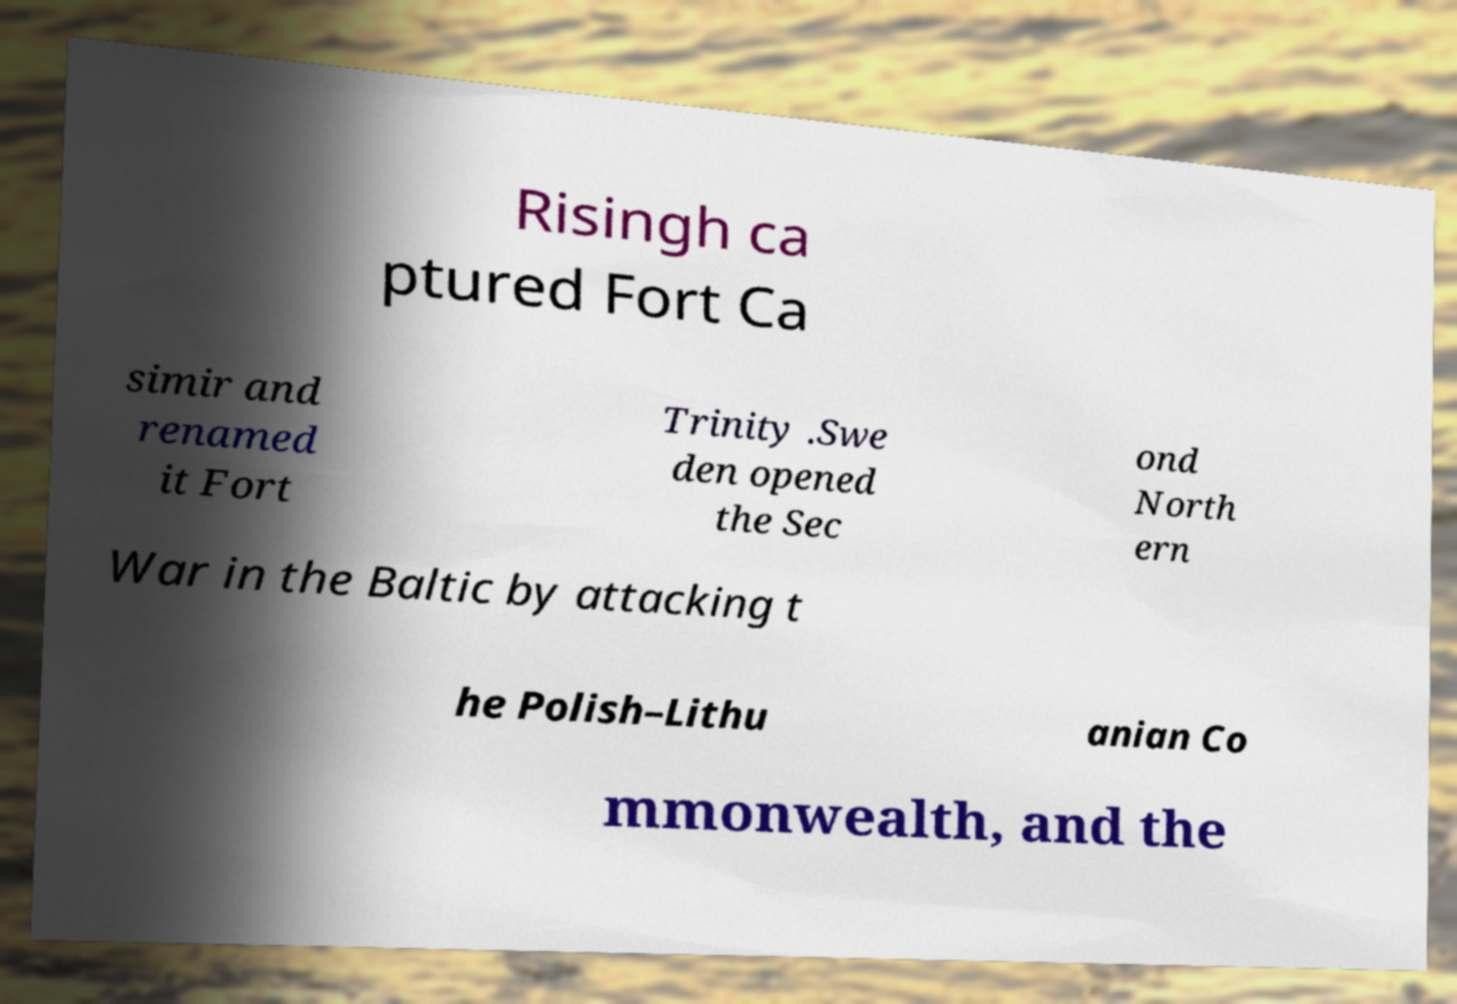Please identify and transcribe the text found in this image. Risingh ca ptured Fort Ca simir and renamed it Fort Trinity .Swe den opened the Sec ond North ern War in the Baltic by attacking t he Polish–Lithu anian Co mmonwealth, and the 